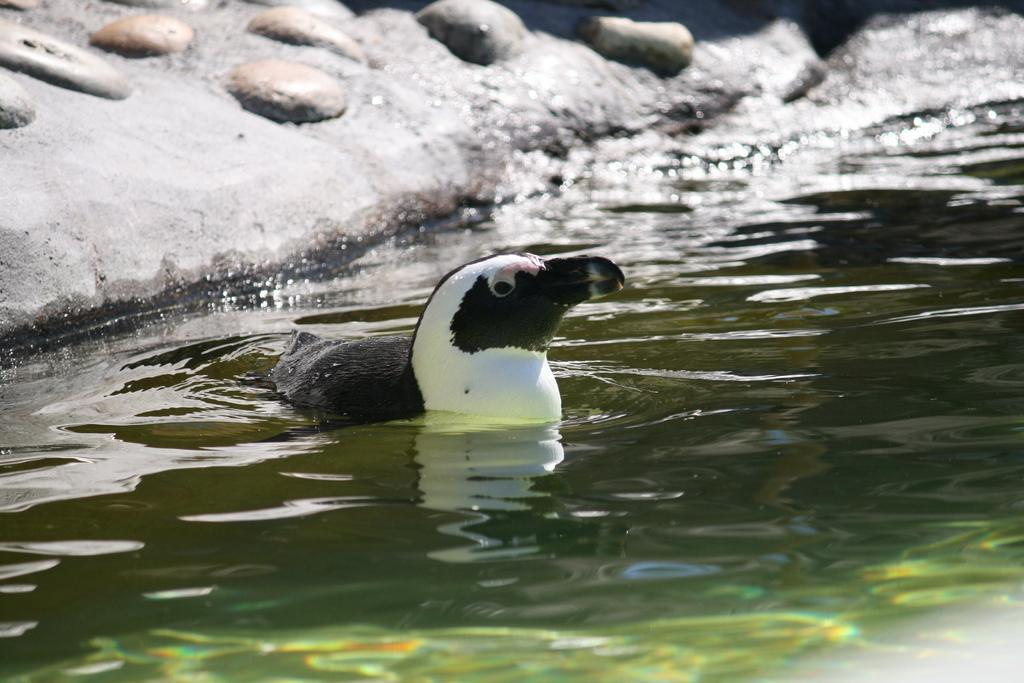What animal is present in the image? There is a duck in the image. Where is the duck located? The duck is in the water. What can be seen in the background of the image? There are rocks in the background of the image. What time of day is it in the image, considering the presence of a turkey? There is no turkey present in the image, so it is not possible to determine the time of day based on that information. 